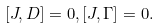<formula> <loc_0><loc_0><loc_500><loc_500>[ J , D ] = 0 , [ J , \Gamma ] = 0 .</formula> 